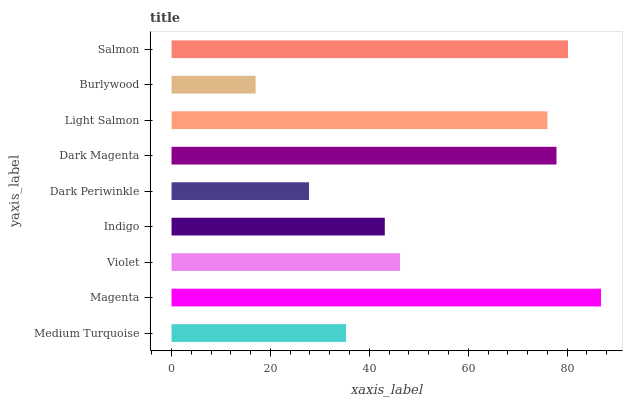Is Burlywood the minimum?
Answer yes or no. Yes. Is Magenta the maximum?
Answer yes or no. Yes. Is Violet the minimum?
Answer yes or no. No. Is Violet the maximum?
Answer yes or no. No. Is Magenta greater than Violet?
Answer yes or no. Yes. Is Violet less than Magenta?
Answer yes or no. Yes. Is Violet greater than Magenta?
Answer yes or no. No. Is Magenta less than Violet?
Answer yes or no. No. Is Violet the high median?
Answer yes or no. Yes. Is Violet the low median?
Answer yes or no. Yes. Is Light Salmon the high median?
Answer yes or no. No. Is Light Salmon the low median?
Answer yes or no. No. 